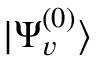<formula> <loc_0><loc_0><loc_500><loc_500>| \Psi _ { v } ^ { ( 0 ) } \rangle</formula> 